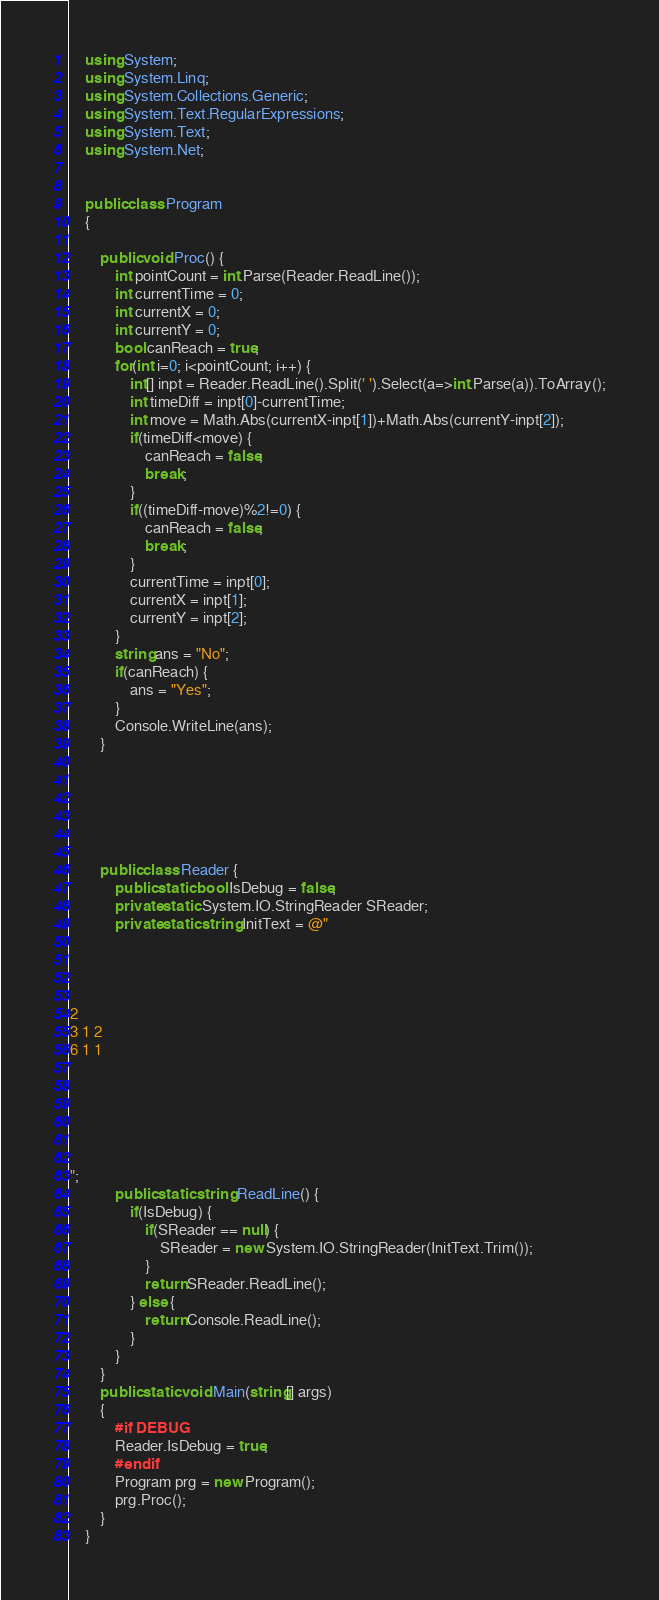Convert code to text. <code><loc_0><loc_0><loc_500><loc_500><_C#_>    using System;
    using System.Linq;
    using System.Collections.Generic;
    using System.Text.RegularExpressions;
    using System.Text;
    using System.Net;

     
    public class Program
    {

        public void Proc() {
            int pointCount = int.Parse(Reader.ReadLine());
            int currentTime = 0;
            int currentX = 0;
            int currentY = 0;
            bool canReach = true;
            for(int i=0; i<pointCount; i++) {
                int[] inpt = Reader.ReadLine().Split(' ').Select(a=>int.Parse(a)).ToArray();
                int timeDiff = inpt[0]-currentTime;
                int move = Math.Abs(currentX-inpt[1])+Math.Abs(currentY-inpt[2]);
                if(timeDiff<move) {
                    canReach = false;
                    break;
                }
                if((timeDiff-move)%2!=0) {
                    canReach = false;
                    break;
                }
                currentTime = inpt[0];
                currentX = inpt[1];
                currentY = inpt[2];
            }
            string ans = "No";
            if(canReach) {
                ans = "Yes";
            }
            Console.WriteLine(ans);
        }






        public class Reader {
            public static bool IsDebug = false;
            private static System.IO.StringReader SReader;
            private static string InitText = @"




2
3 1 2
6 1 1






";
            public static string ReadLine() {
                if(IsDebug) {
                    if(SReader == null) {
                        SReader = new System.IO.StringReader(InitText.Trim());
                    }
                    return SReader.ReadLine();
                } else {
                    return Console.ReadLine();
                }
            }
        }
        public static void Main(string[] args)
        {
            #if DEBUG
            Reader.IsDebug = true;
            #endif
            Program prg = new Program();
            prg.Proc();
        }
    }</code> 